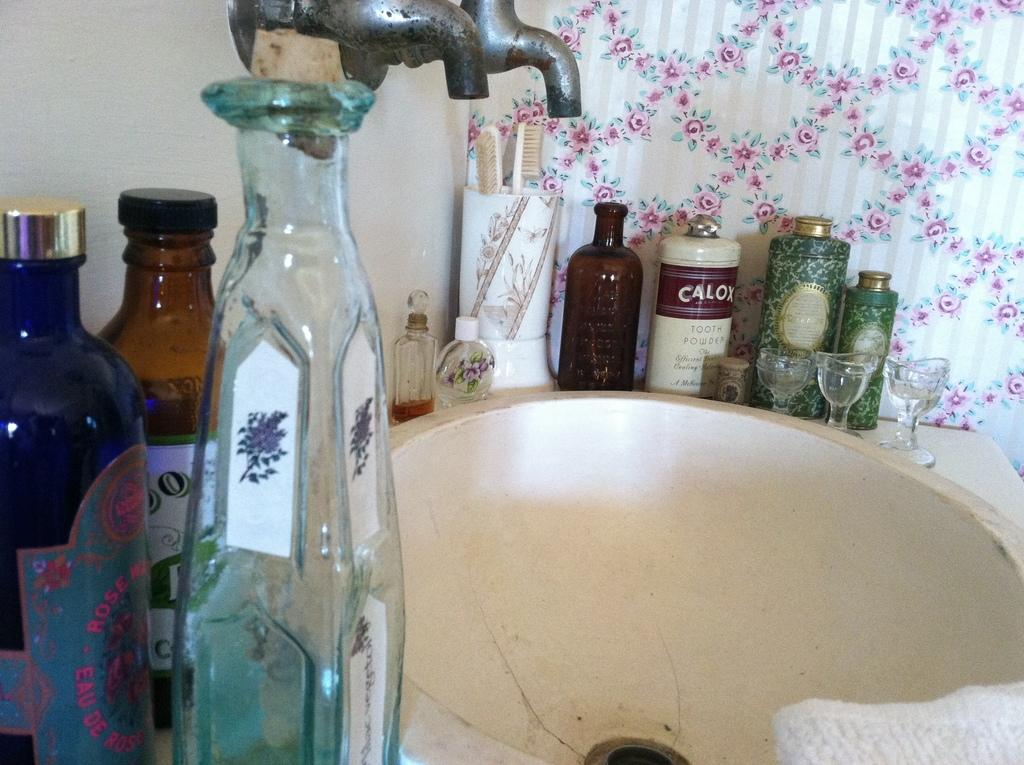What objects are located in the front left of the image? There are glass bottles in the front left of the image. What can be seen in the center of the image? There are two taps and a basin in the center of the image. What is the toothbrush used for? The toothbrush is used for cleaning teeth. What type of containers are present in the image? There are glasses and bottles in the image. What can be found in the background of the image? There are curtains in the background of the image. What type of hat is hanging on the toothbrush in the image? There is no hat present in the image, and the toothbrush is not associated with any hat. 